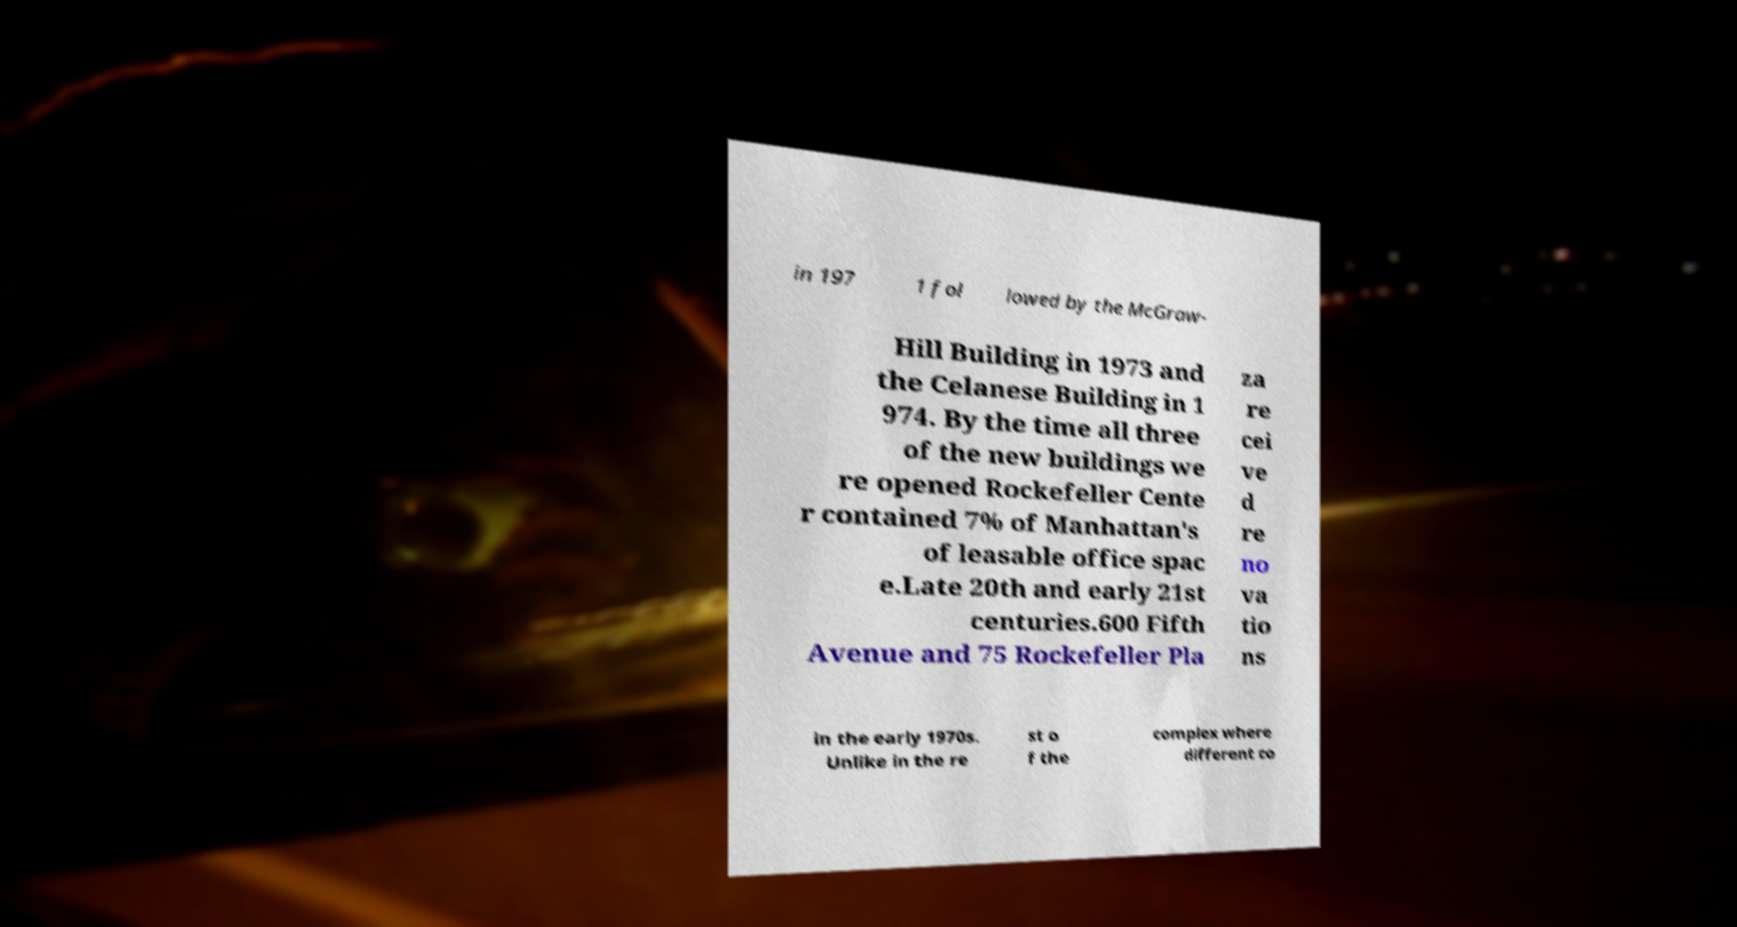Can you accurately transcribe the text from the provided image for me? in 197 1 fol lowed by the McGraw- Hill Building in 1973 and the Celanese Building in 1 974. By the time all three of the new buildings we re opened Rockefeller Cente r contained 7% of Manhattan's of leasable office spac e.Late 20th and early 21st centuries.600 Fifth Avenue and 75 Rockefeller Pla za re cei ve d re no va tio ns in the early 1970s. Unlike in the re st o f the complex where different co 